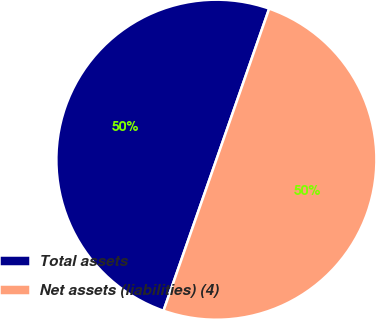<chart> <loc_0><loc_0><loc_500><loc_500><pie_chart><fcel>Total assets<fcel>Net assets (liabilities) (4)<nl><fcel>49.99%<fcel>50.01%<nl></chart> 